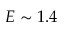Convert formula to latex. <formula><loc_0><loc_0><loc_500><loc_500>E \sim 1 . 4</formula> 